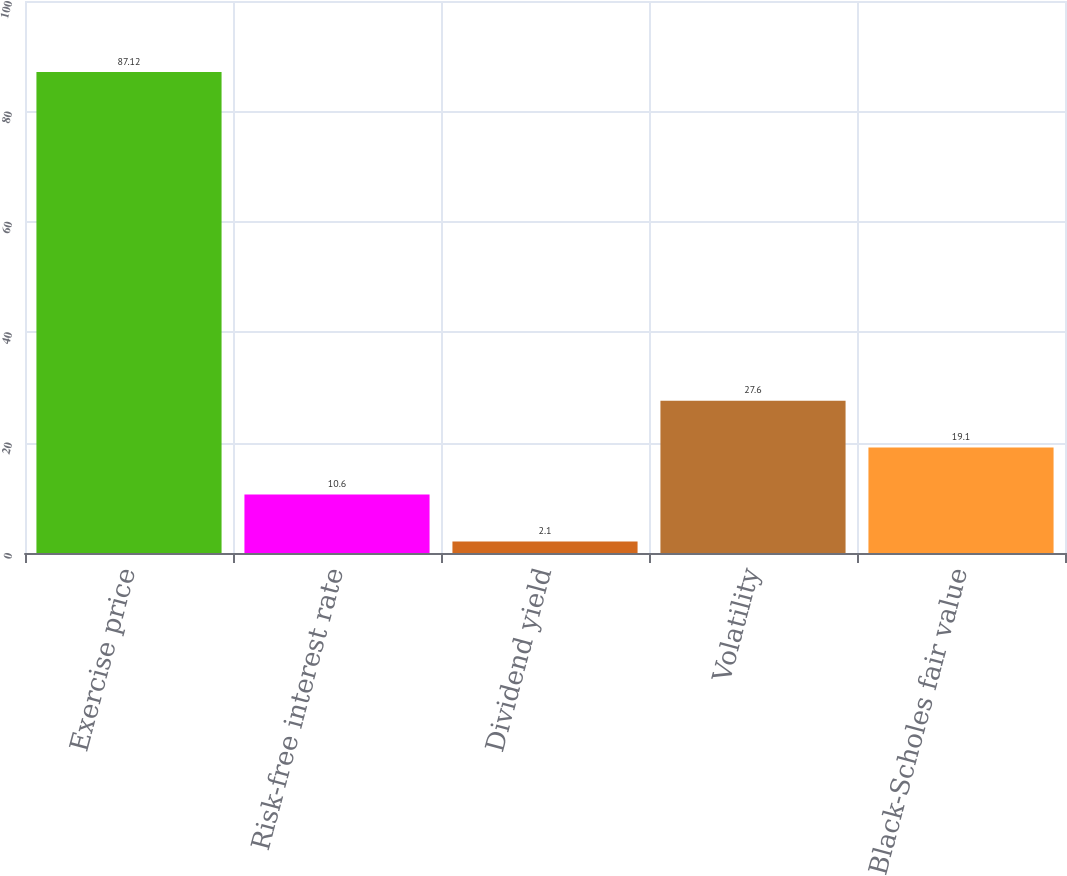Convert chart to OTSL. <chart><loc_0><loc_0><loc_500><loc_500><bar_chart><fcel>Exercise price<fcel>Risk-free interest rate<fcel>Dividend yield<fcel>Volatility<fcel>Black-Scholes fair value<nl><fcel>87.12<fcel>10.6<fcel>2.1<fcel>27.6<fcel>19.1<nl></chart> 